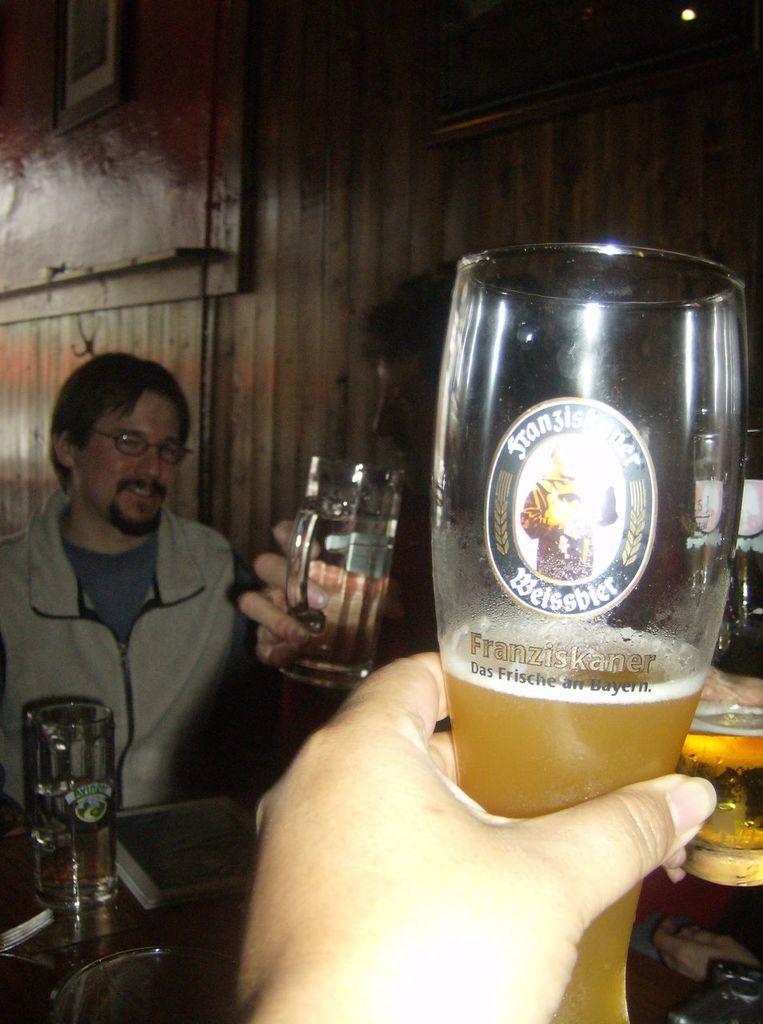Can you describe this image briefly? There is a human hand in this picture, holding a glass in which some drink is there. In the background there is another one holding a glass and some of them are sitting here. There is a wall here. 